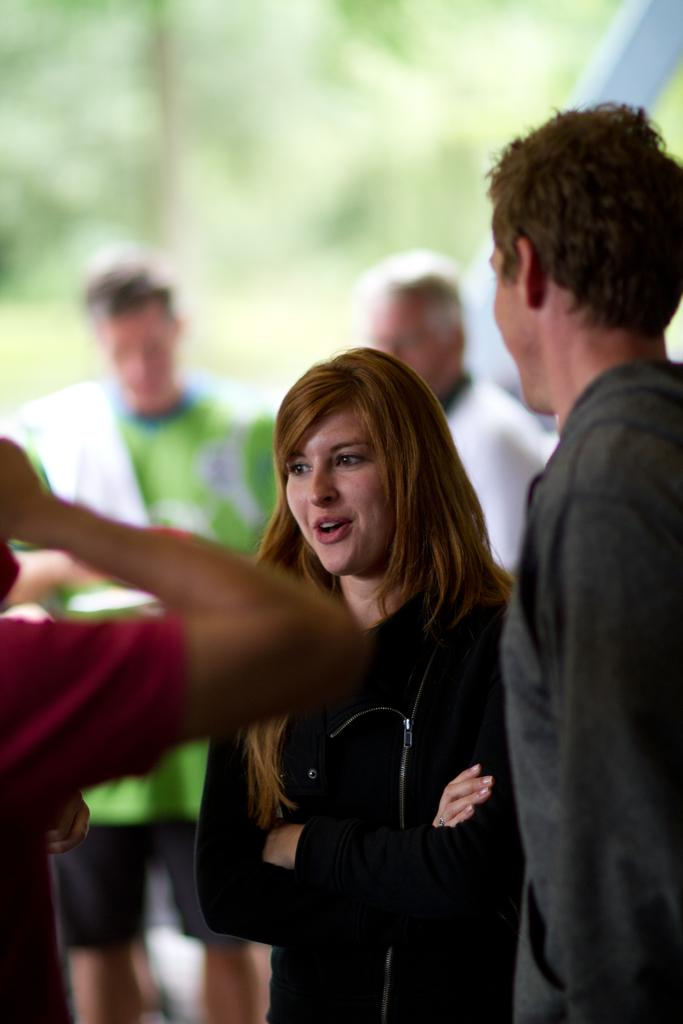How many people are present in the image? There are four persons standing in the image. Can you describe any specific body parts visible in the image? A person's hand is visible on the left side of the image. What can be said about the background of the image? The background of the image is blurred. What type of argument is taking place between the persons in the image? There is no indication of an argument in the image; it only shows four persons standing. Can you describe the bomb that is visible in the image? There is no bomb present in the image. 